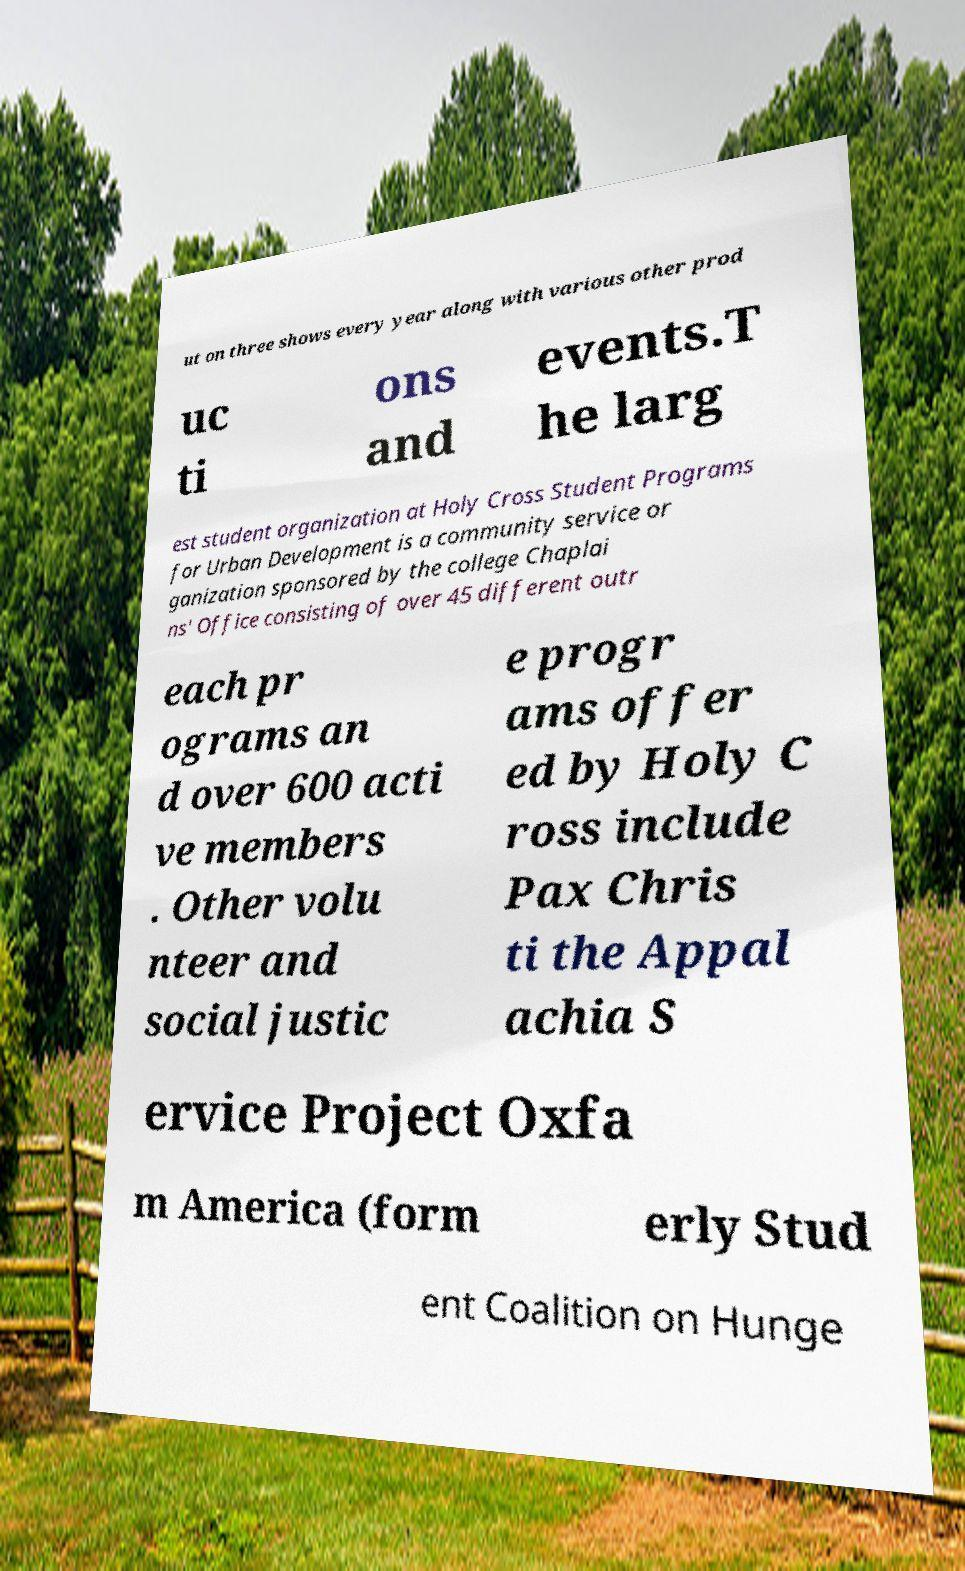There's text embedded in this image that I need extracted. Can you transcribe it verbatim? ut on three shows every year along with various other prod uc ti ons and events.T he larg est student organization at Holy Cross Student Programs for Urban Development is a community service or ganization sponsored by the college Chaplai ns' Office consisting of over 45 different outr each pr ograms an d over 600 acti ve members . Other volu nteer and social justic e progr ams offer ed by Holy C ross include Pax Chris ti the Appal achia S ervice Project Oxfa m America (form erly Stud ent Coalition on Hunge 